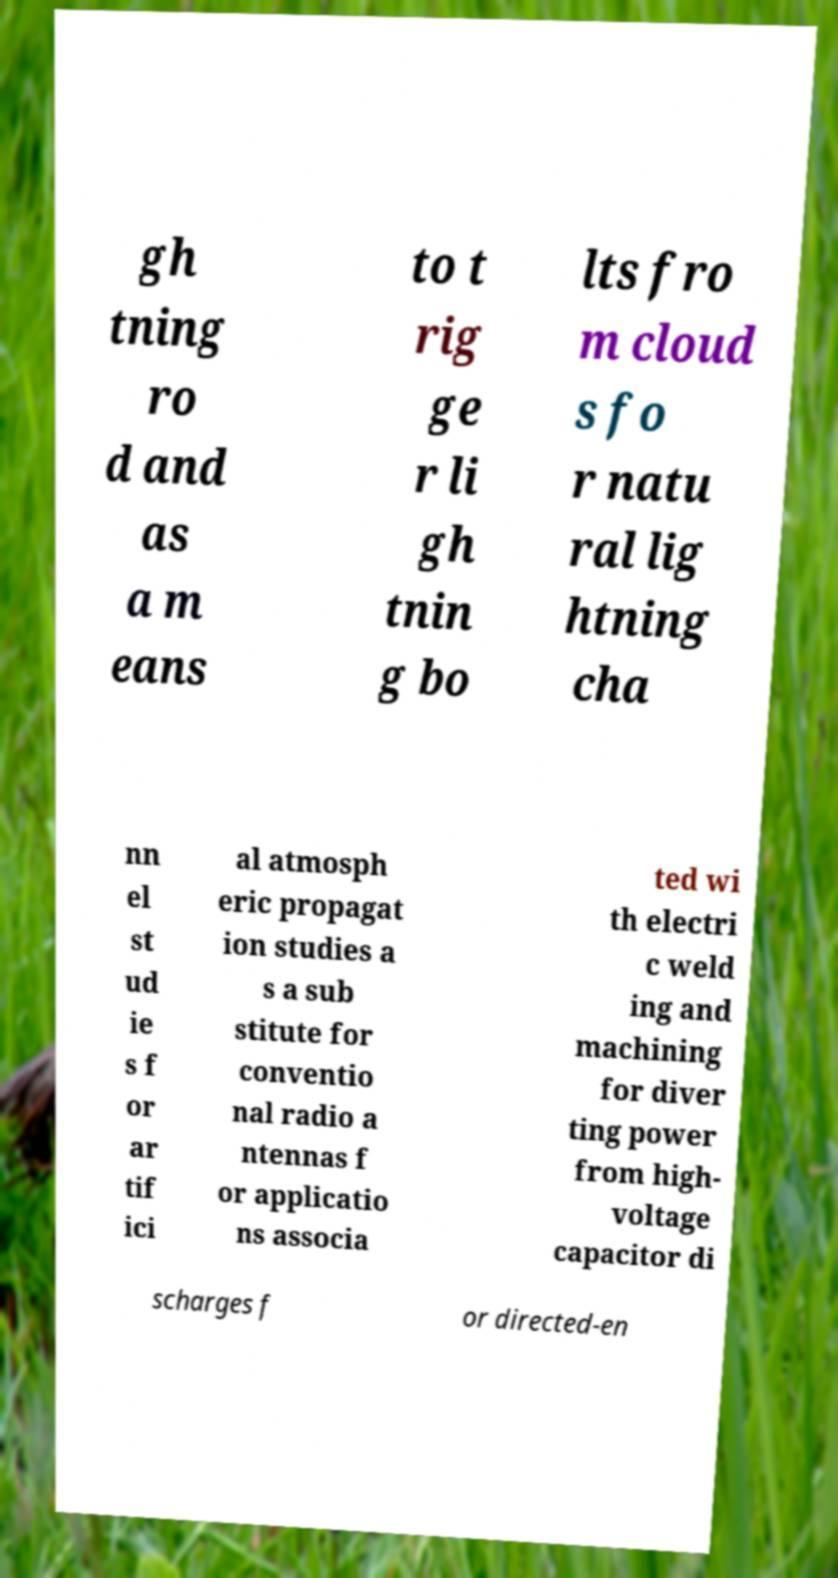For documentation purposes, I need the text within this image transcribed. Could you provide that? gh tning ro d and as a m eans to t rig ge r li gh tnin g bo lts fro m cloud s fo r natu ral lig htning cha nn el st ud ie s f or ar tif ici al atmosph eric propagat ion studies a s a sub stitute for conventio nal radio a ntennas f or applicatio ns associa ted wi th electri c weld ing and machining for diver ting power from high- voltage capacitor di scharges f or directed-en 